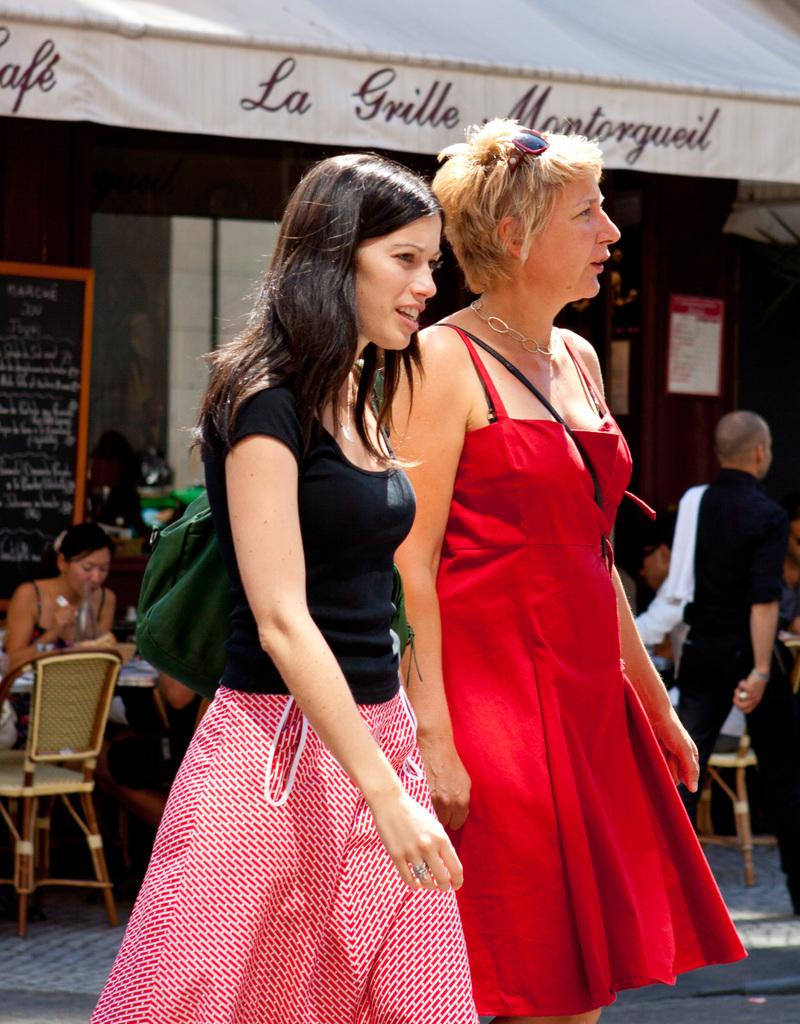What are the women in the image doing? There are two women walking in the image. Can you describe the position of the third person in the image? There is a woman sitting on a chair in the image. What is the man in the image doing? There is a man walking in the image. What type of stocking is the man wearing in the image? There is no mention of stockings in the image, and the man's attire is not described. What scent can be detected in the image? There is no mention of any scent in the image. 